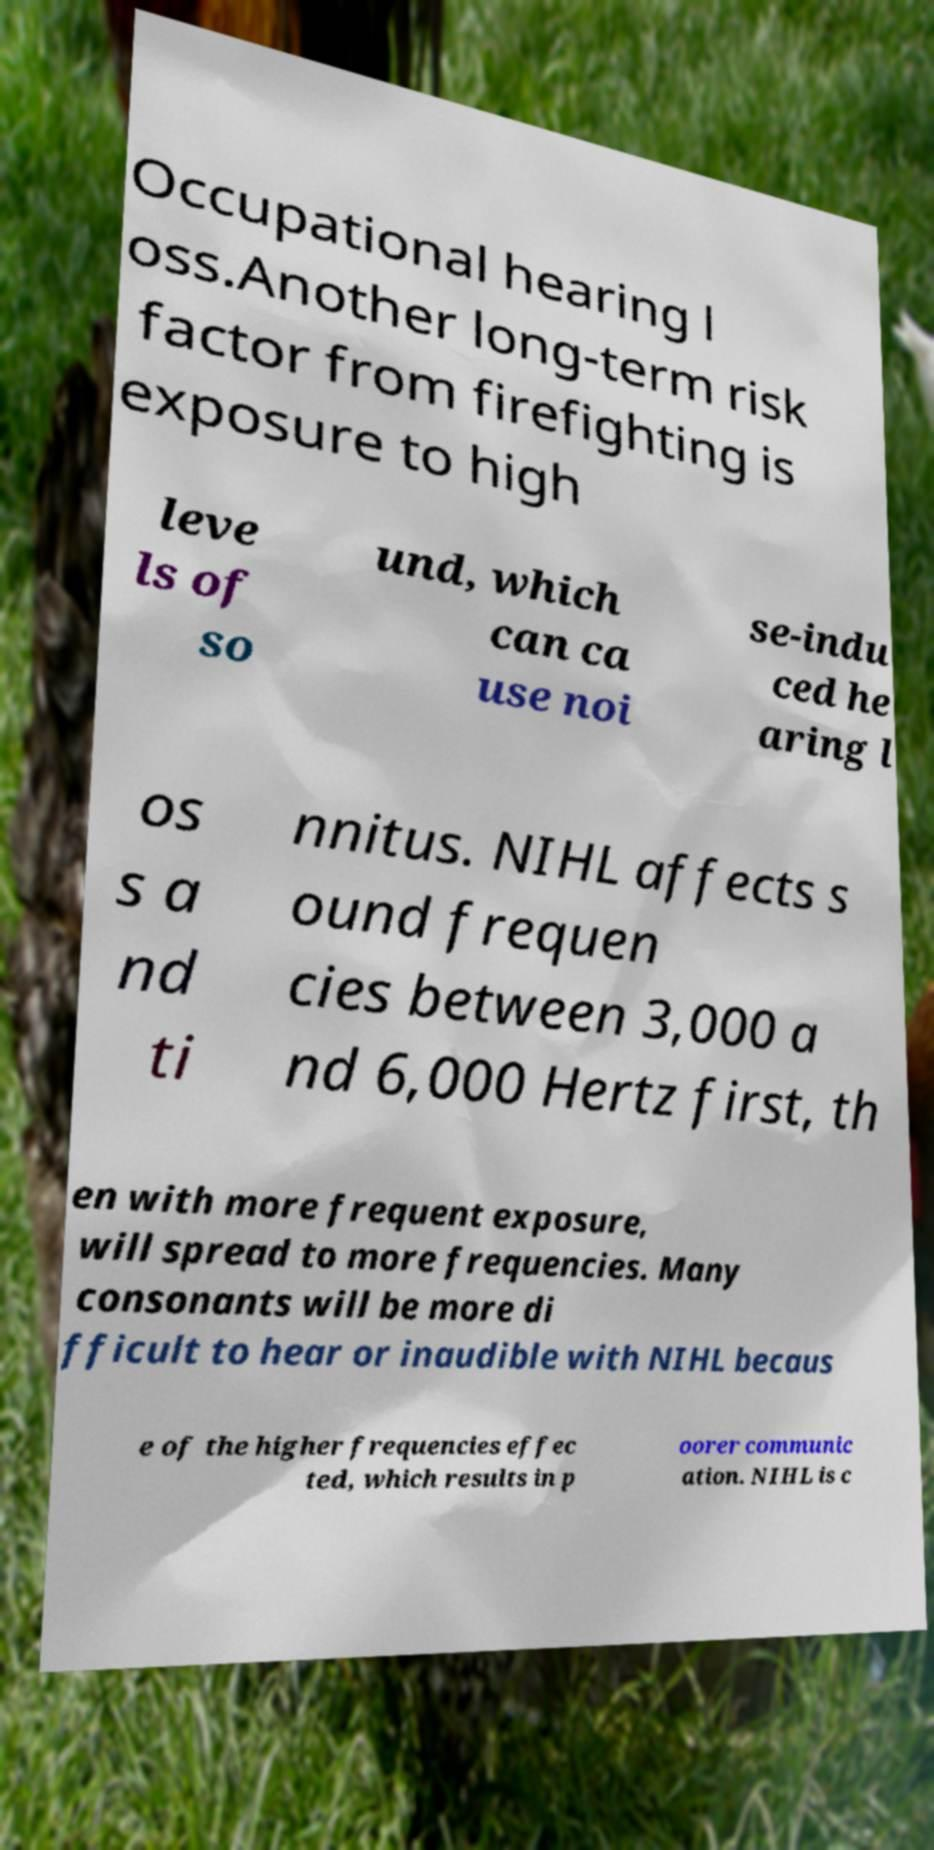There's text embedded in this image that I need extracted. Can you transcribe it verbatim? Occupational hearing l oss.Another long-term risk factor from firefighting is exposure to high leve ls of so und, which can ca use noi se-indu ced he aring l os s a nd ti nnitus. NIHL affects s ound frequen cies between 3,000 a nd 6,000 Hertz first, th en with more frequent exposure, will spread to more frequencies. Many consonants will be more di fficult to hear or inaudible with NIHL becaus e of the higher frequencies effec ted, which results in p oorer communic ation. NIHL is c 